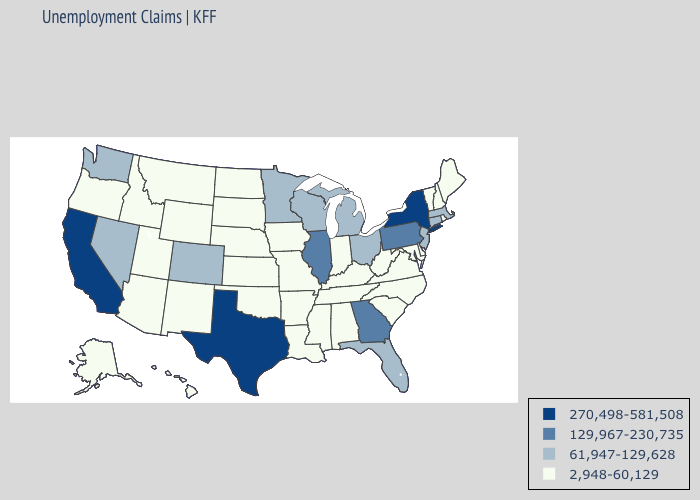What is the lowest value in the USA?
Quick response, please. 2,948-60,129. What is the highest value in the MidWest ?
Write a very short answer. 129,967-230,735. What is the lowest value in the USA?
Give a very brief answer. 2,948-60,129. Does Oklahoma have the same value as Minnesota?
Concise answer only. No. Among the states that border New Mexico , does Utah have the lowest value?
Concise answer only. Yes. What is the highest value in states that border Texas?
Be succinct. 2,948-60,129. Does Alaska have the same value as Texas?
Short answer required. No. What is the lowest value in the USA?
Answer briefly. 2,948-60,129. What is the lowest value in the MidWest?
Concise answer only. 2,948-60,129. Among the states that border Ohio , does Kentucky have the highest value?
Be succinct. No. Name the states that have a value in the range 2,948-60,129?
Be succinct. Alabama, Alaska, Arizona, Arkansas, Delaware, Hawaii, Idaho, Indiana, Iowa, Kansas, Kentucky, Louisiana, Maine, Maryland, Mississippi, Missouri, Montana, Nebraska, New Hampshire, New Mexico, North Carolina, North Dakota, Oklahoma, Oregon, Rhode Island, South Carolina, South Dakota, Tennessee, Utah, Vermont, Virginia, West Virginia, Wyoming. Does Texas have the highest value in the South?
Short answer required. Yes. What is the value of New Mexico?
Keep it brief. 2,948-60,129. Name the states that have a value in the range 270,498-581,508?
Be succinct. California, New York, Texas. Among the states that border New Jersey , does Delaware have the highest value?
Short answer required. No. 